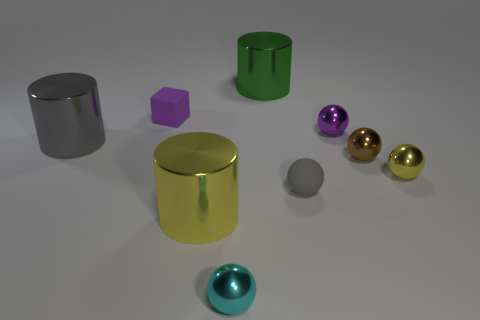Subtract all green cylinders. How many cylinders are left? 2 Subtract all yellow balls. How many balls are left? 4 Subtract all balls. How many objects are left? 4 Subtract all gray spheres. Subtract all gray cubes. How many spheres are left? 4 Add 4 tiny red metallic cylinders. How many tiny red metallic cylinders exist? 4 Subtract 1 cyan spheres. How many objects are left? 8 Subtract all large green shiny cylinders. Subtract all tiny red metal cylinders. How many objects are left? 8 Add 3 large metallic cylinders. How many large metallic cylinders are left? 6 